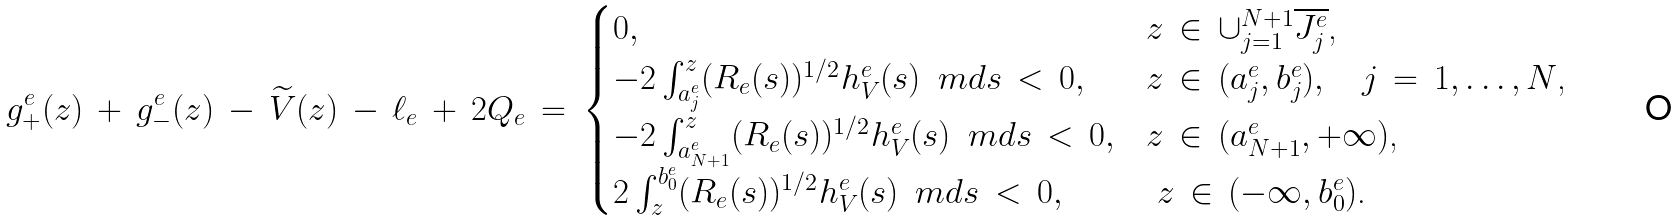Convert formula to latex. <formula><loc_0><loc_0><loc_500><loc_500>g ^ { e } _ { + } ( z ) \, + \, g ^ { e } _ { - } ( z ) \, - \, \widetilde { V } ( z ) \, - \, \ell _ { e } \, + \, 2 Q _ { e } \, = \, \begin{cases} 0 , & \text {$z \, \in \, \cup_{j=1}^{N+1} \overline{J_{j}^{e}}$,} \\ - 2 \int _ { a _ { j } ^ { e } } ^ { z } ( R _ { e } ( s ) ) ^ { 1 / 2 } h _ { V } ^ { e } ( s ) \, \ m d s \, < \, 0 , & \text {$z \, \in \, (a_{j}^{e},b_{j}^{e}), \quad j \, = \, 1,\dotsc,N$,} \\ - 2 \int _ { a _ { N + 1 } ^ { e } } ^ { z } ( R _ { e } ( s ) ) ^ { 1 / 2 } h _ { V } ^ { e } ( s ) \, \ m d s \, < \, 0 , & \text {$z \, \in \, (a_{N+1}^{e},+\infty)$,} \\ 2 \int _ { z } ^ { b _ { 0 } ^ { e } } ( R _ { e } ( s ) ) ^ { 1 / 2 } h _ { V } ^ { e } ( s ) \, \ m d s \, < \, 0 , & \text { $z \, \in \, (-\infty,b_{0}^{e})$.} \end{cases}</formula> 